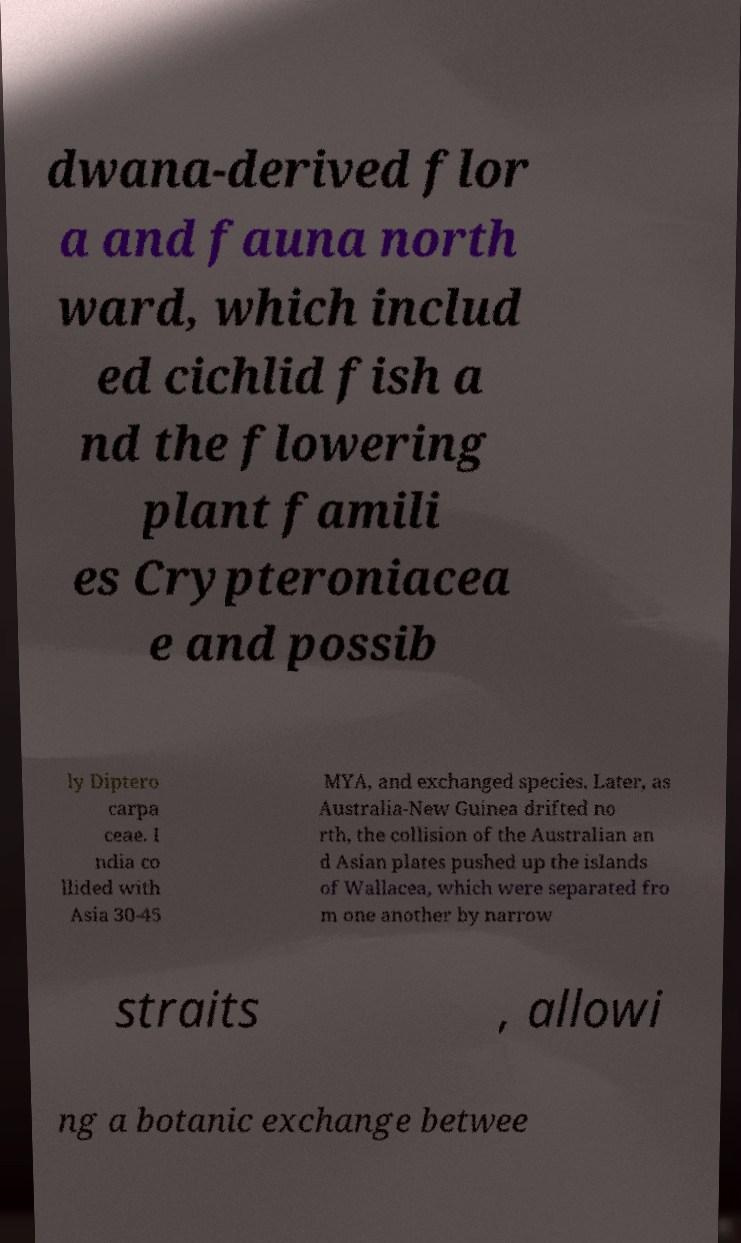Could you extract and type out the text from this image? dwana-derived flor a and fauna north ward, which includ ed cichlid fish a nd the flowering plant famili es Crypteroniacea e and possib ly Diptero carpa ceae. I ndia co llided with Asia 30-45 MYA, and exchanged species. Later, as Australia-New Guinea drifted no rth, the collision of the Australian an d Asian plates pushed up the islands of Wallacea, which were separated fro m one another by narrow straits , allowi ng a botanic exchange betwee 